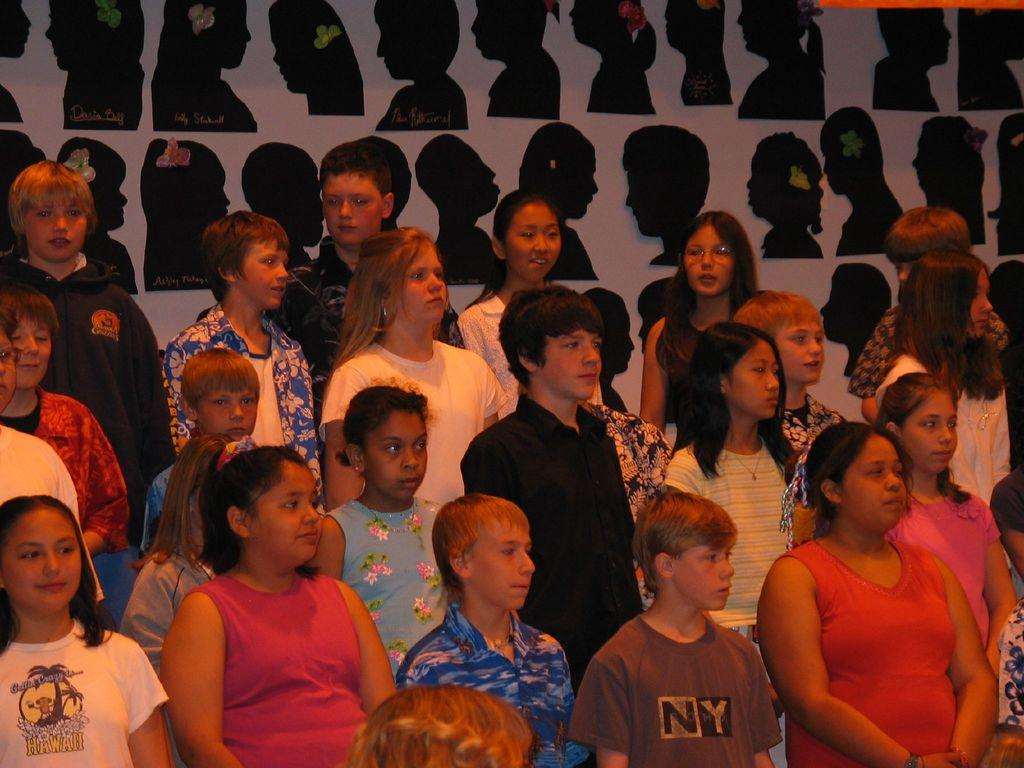How many people are in the image? There is a group of people in the image, but the exact number is not specified. What can be seen in the background of the image? There are pictures attached to a wall in the background of the image. Can you see any visible teeth in the image? There is no reference to teeth or any dental-related elements in the image. 